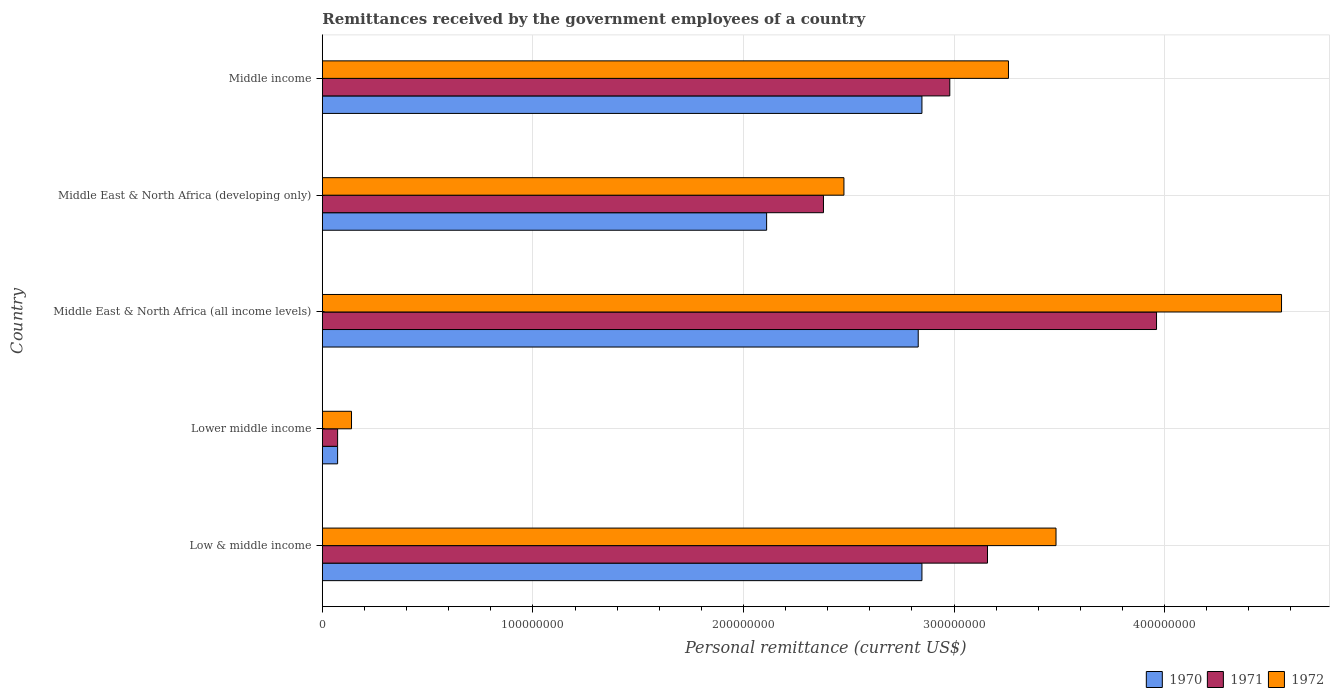How many different coloured bars are there?
Your response must be concise. 3. Are the number of bars on each tick of the Y-axis equal?
Ensure brevity in your answer.  Yes. How many bars are there on the 3rd tick from the top?
Offer a very short reply. 3. What is the remittances received by the government employees in 1970 in Lower middle income?
Your response must be concise. 7.26e+06. Across all countries, what is the maximum remittances received by the government employees in 1970?
Give a very brief answer. 2.85e+08. Across all countries, what is the minimum remittances received by the government employees in 1970?
Keep it short and to the point. 7.26e+06. In which country was the remittances received by the government employees in 1972 maximum?
Keep it short and to the point. Middle East & North Africa (all income levels). In which country was the remittances received by the government employees in 1971 minimum?
Provide a succinct answer. Lower middle income. What is the total remittances received by the government employees in 1972 in the graph?
Your response must be concise. 1.39e+09. What is the difference between the remittances received by the government employees in 1971 in Low & middle income and that in Lower middle income?
Make the answer very short. 3.09e+08. What is the difference between the remittances received by the government employees in 1971 in Lower middle income and the remittances received by the government employees in 1972 in Low & middle income?
Offer a very short reply. -3.41e+08. What is the average remittances received by the government employees in 1970 per country?
Your response must be concise. 2.14e+08. What is the difference between the remittances received by the government employees in 1970 and remittances received by the government employees in 1971 in Low & middle income?
Your answer should be very brief. -3.11e+07. In how many countries, is the remittances received by the government employees in 1972 greater than 180000000 US$?
Your response must be concise. 4. What is the ratio of the remittances received by the government employees in 1972 in Low & middle income to that in Middle income?
Your response must be concise. 1.07. Is the difference between the remittances received by the government employees in 1970 in Middle East & North Africa (all income levels) and Middle income greater than the difference between the remittances received by the government employees in 1971 in Middle East & North Africa (all income levels) and Middle income?
Give a very brief answer. No. What is the difference between the highest and the second highest remittances received by the government employees in 1971?
Ensure brevity in your answer.  8.03e+07. What is the difference between the highest and the lowest remittances received by the government employees in 1970?
Your response must be concise. 2.77e+08. In how many countries, is the remittances received by the government employees in 1970 greater than the average remittances received by the government employees in 1970 taken over all countries?
Provide a short and direct response. 3. What does the 2nd bar from the top in Middle income represents?
Give a very brief answer. 1971. How many bars are there?
Your response must be concise. 15. How many countries are there in the graph?
Offer a very short reply. 5. What is the difference between two consecutive major ticks on the X-axis?
Provide a succinct answer. 1.00e+08. Does the graph contain any zero values?
Make the answer very short. No. Where does the legend appear in the graph?
Ensure brevity in your answer.  Bottom right. How many legend labels are there?
Offer a very short reply. 3. What is the title of the graph?
Give a very brief answer. Remittances received by the government employees of a country. What is the label or title of the X-axis?
Your answer should be very brief. Personal remittance (current US$). What is the label or title of the Y-axis?
Your answer should be compact. Country. What is the Personal remittance (current US$) in 1970 in Low & middle income?
Offer a very short reply. 2.85e+08. What is the Personal remittance (current US$) in 1971 in Low & middle income?
Give a very brief answer. 3.16e+08. What is the Personal remittance (current US$) in 1972 in Low & middle income?
Keep it short and to the point. 3.48e+08. What is the Personal remittance (current US$) of 1970 in Lower middle income?
Your answer should be very brief. 7.26e+06. What is the Personal remittance (current US$) of 1971 in Lower middle income?
Provide a short and direct response. 7.26e+06. What is the Personal remittance (current US$) of 1972 in Lower middle income?
Give a very brief answer. 1.39e+07. What is the Personal remittance (current US$) in 1970 in Middle East & North Africa (all income levels)?
Ensure brevity in your answer.  2.83e+08. What is the Personal remittance (current US$) of 1971 in Middle East & North Africa (all income levels)?
Your response must be concise. 3.96e+08. What is the Personal remittance (current US$) in 1972 in Middle East & North Africa (all income levels)?
Offer a very short reply. 4.56e+08. What is the Personal remittance (current US$) of 1970 in Middle East & North Africa (developing only)?
Your answer should be very brief. 2.11e+08. What is the Personal remittance (current US$) of 1971 in Middle East & North Africa (developing only)?
Give a very brief answer. 2.38e+08. What is the Personal remittance (current US$) in 1972 in Middle East & North Africa (developing only)?
Offer a very short reply. 2.48e+08. What is the Personal remittance (current US$) in 1970 in Middle income?
Give a very brief answer. 2.85e+08. What is the Personal remittance (current US$) in 1971 in Middle income?
Your answer should be compact. 2.98e+08. What is the Personal remittance (current US$) in 1972 in Middle income?
Offer a very short reply. 3.26e+08. Across all countries, what is the maximum Personal remittance (current US$) in 1970?
Your answer should be compact. 2.85e+08. Across all countries, what is the maximum Personal remittance (current US$) in 1971?
Your answer should be compact. 3.96e+08. Across all countries, what is the maximum Personal remittance (current US$) of 1972?
Give a very brief answer. 4.56e+08. Across all countries, what is the minimum Personal remittance (current US$) of 1970?
Your answer should be very brief. 7.26e+06. Across all countries, what is the minimum Personal remittance (current US$) of 1971?
Your answer should be compact. 7.26e+06. Across all countries, what is the minimum Personal remittance (current US$) of 1972?
Offer a terse response. 1.39e+07. What is the total Personal remittance (current US$) of 1970 in the graph?
Your answer should be very brief. 1.07e+09. What is the total Personal remittance (current US$) in 1971 in the graph?
Your response must be concise. 1.26e+09. What is the total Personal remittance (current US$) of 1972 in the graph?
Give a very brief answer. 1.39e+09. What is the difference between the Personal remittance (current US$) of 1970 in Low & middle income and that in Lower middle income?
Your answer should be very brief. 2.77e+08. What is the difference between the Personal remittance (current US$) in 1971 in Low & middle income and that in Lower middle income?
Provide a succinct answer. 3.09e+08. What is the difference between the Personal remittance (current US$) of 1972 in Low & middle income and that in Lower middle income?
Your response must be concise. 3.35e+08. What is the difference between the Personal remittance (current US$) in 1970 in Low & middle income and that in Middle East & North Africa (all income levels)?
Make the answer very short. 1.76e+06. What is the difference between the Personal remittance (current US$) in 1971 in Low & middle income and that in Middle East & North Africa (all income levels)?
Provide a succinct answer. -8.03e+07. What is the difference between the Personal remittance (current US$) of 1972 in Low & middle income and that in Middle East & North Africa (all income levels)?
Ensure brevity in your answer.  -1.07e+08. What is the difference between the Personal remittance (current US$) in 1970 in Low & middle income and that in Middle East & North Africa (developing only)?
Your answer should be compact. 7.38e+07. What is the difference between the Personal remittance (current US$) of 1971 in Low & middle income and that in Middle East & North Africa (developing only)?
Make the answer very short. 7.79e+07. What is the difference between the Personal remittance (current US$) in 1972 in Low & middle income and that in Middle East & North Africa (developing only)?
Keep it short and to the point. 1.01e+08. What is the difference between the Personal remittance (current US$) in 1970 in Low & middle income and that in Middle income?
Keep it short and to the point. 0. What is the difference between the Personal remittance (current US$) in 1971 in Low & middle income and that in Middle income?
Ensure brevity in your answer.  1.79e+07. What is the difference between the Personal remittance (current US$) of 1972 in Low & middle income and that in Middle income?
Give a very brief answer. 2.26e+07. What is the difference between the Personal remittance (current US$) in 1970 in Lower middle income and that in Middle East & North Africa (all income levels)?
Give a very brief answer. -2.76e+08. What is the difference between the Personal remittance (current US$) in 1971 in Lower middle income and that in Middle East & North Africa (all income levels)?
Make the answer very short. -3.89e+08. What is the difference between the Personal remittance (current US$) of 1972 in Lower middle income and that in Middle East & North Africa (all income levels)?
Offer a very short reply. -4.42e+08. What is the difference between the Personal remittance (current US$) in 1970 in Lower middle income and that in Middle East & North Africa (developing only)?
Your answer should be very brief. -2.04e+08. What is the difference between the Personal remittance (current US$) in 1971 in Lower middle income and that in Middle East & North Africa (developing only)?
Offer a very short reply. -2.31e+08. What is the difference between the Personal remittance (current US$) of 1972 in Lower middle income and that in Middle East & North Africa (developing only)?
Ensure brevity in your answer.  -2.34e+08. What is the difference between the Personal remittance (current US$) of 1970 in Lower middle income and that in Middle income?
Your response must be concise. -2.77e+08. What is the difference between the Personal remittance (current US$) of 1971 in Lower middle income and that in Middle income?
Ensure brevity in your answer.  -2.91e+08. What is the difference between the Personal remittance (current US$) in 1972 in Lower middle income and that in Middle income?
Your answer should be compact. -3.12e+08. What is the difference between the Personal remittance (current US$) in 1970 in Middle East & North Africa (all income levels) and that in Middle East & North Africa (developing only)?
Give a very brief answer. 7.20e+07. What is the difference between the Personal remittance (current US$) of 1971 in Middle East & North Africa (all income levels) and that in Middle East & North Africa (developing only)?
Your answer should be compact. 1.58e+08. What is the difference between the Personal remittance (current US$) of 1972 in Middle East & North Africa (all income levels) and that in Middle East & North Africa (developing only)?
Ensure brevity in your answer.  2.08e+08. What is the difference between the Personal remittance (current US$) of 1970 in Middle East & North Africa (all income levels) and that in Middle income?
Provide a succinct answer. -1.76e+06. What is the difference between the Personal remittance (current US$) of 1971 in Middle East & North Africa (all income levels) and that in Middle income?
Your answer should be very brief. 9.82e+07. What is the difference between the Personal remittance (current US$) of 1972 in Middle East & North Africa (all income levels) and that in Middle income?
Provide a succinct answer. 1.30e+08. What is the difference between the Personal remittance (current US$) of 1970 in Middle East & North Africa (developing only) and that in Middle income?
Ensure brevity in your answer.  -7.38e+07. What is the difference between the Personal remittance (current US$) of 1971 in Middle East & North Africa (developing only) and that in Middle income?
Offer a very short reply. -6.00e+07. What is the difference between the Personal remittance (current US$) in 1972 in Middle East & North Africa (developing only) and that in Middle income?
Provide a succinct answer. -7.81e+07. What is the difference between the Personal remittance (current US$) of 1970 in Low & middle income and the Personal remittance (current US$) of 1971 in Lower middle income?
Offer a terse response. 2.77e+08. What is the difference between the Personal remittance (current US$) of 1970 in Low & middle income and the Personal remittance (current US$) of 1972 in Lower middle income?
Your answer should be compact. 2.71e+08. What is the difference between the Personal remittance (current US$) in 1971 in Low & middle income and the Personal remittance (current US$) in 1972 in Lower middle income?
Offer a terse response. 3.02e+08. What is the difference between the Personal remittance (current US$) in 1970 in Low & middle income and the Personal remittance (current US$) in 1971 in Middle East & North Africa (all income levels)?
Provide a succinct answer. -1.11e+08. What is the difference between the Personal remittance (current US$) of 1970 in Low & middle income and the Personal remittance (current US$) of 1972 in Middle East & North Africa (all income levels)?
Keep it short and to the point. -1.71e+08. What is the difference between the Personal remittance (current US$) of 1971 in Low & middle income and the Personal remittance (current US$) of 1972 in Middle East & North Africa (all income levels)?
Make the answer very short. -1.40e+08. What is the difference between the Personal remittance (current US$) of 1970 in Low & middle income and the Personal remittance (current US$) of 1971 in Middle East & North Africa (developing only)?
Your answer should be compact. 4.68e+07. What is the difference between the Personal remittance (current US$) in 1970 in Low & middle income and the Personal remittance (current US$) in 1972 in Middle East & North Africa (developing only)?
Offer a very short reply. 3.70e+07. What is the difference between the Personal remittance (current US$) of 1971 in Low & middle income and the Personal remittance (current US$) of 1972 in Middle East & North Africa (developing only)?
Offer a terse response. 6.82e+07. What is the difference between the Personal remittance (current US$) of 1970 in Low & middle income and the Personal remittance (current US$) of 1971 in Middle income?
Ensure brevity in your answer.  -1.32e+07. What is the difference between the Personal remittance (current US$) in 1970 in Low & middle income and the Personal remittance (current US$) in 1972 in Middle income?
Offer a very short reply. -4.11e+07. What is the difference between the Personal remittance (current US$) of 1971 in Low & middle income and the Personal remittance (current US$) of 1972 in Middle income?
Give a very brief answer. -9.96e+06. What is the difference between the Personal remittance (current US$) in 1970 in Lower middle income and the Personal remittance (current US$) in 1971 in Middle East & North Africa (all income levels)?
Your answer should be very brief. -3.89e+08. What is the difference between the Personal remittance (current US$) of 1970 in Lower middle income and the Personal remittance (current US$) of 1972 in Middle East & North Africa (all income levels)?
Your answer should be compact. -4.48e+08. What is the difference between the Personal remittance (current US$) in 1971 in Lower middle income and the Personal remittance (current US$) in 1972 in Middle East & North Africa (all income levels)?
Offer a very short reply. -4.48e+08. What is the difference between the Personal remittance (current US$) of 1970 in Lower middle income and the Personal remittance (current US$) of 1971 in Middle East & North Africa (developing only)?
Your response must be concise. -2.31e+08. What is the difference between the Personal remittance (current US$) in 1970 in Lower middle income and the Personal remittance (current US$) in 1972 in Middle East & North Africa (developing only)?
Your answer should be compact. -2.40e+08. What is the difference between the Personal remittance (current US$) of 1971 in Lower middle income and the Personal remittance (current US$) of 1972 in Middle East & North Africa (developing only)?
Provide a short and direct response. -2.40e+08. What is the difference between the Personal remittance (current US$) of 1970 in Lower middle income and the Personal remittance (current US$) of 1971 in Middle income?
Your response must be concise. -2.91e+08. What is the difference between the Personal remittance (current US$) in 1970 in Lower middle income and the Personal remittance (current US$) in 1972 in Middle income?
Provide a succinct answer. -3.19e+08. What is the difference between the Personal remittance (current US$) of 1971 in Lower middle income and the Personal remittance (current US$) of 1972 in Middle income?
Provide a succinct answer. -3.19e+08. What is the difference between the Personal remittance (current US$) in 1970 in Middle East & North Africa (all income levels) and the Personal remittance (current US$) in 1971 in Middle East & North Africa (developing only)?
Provide a succinct answer. 4.50e+07. What is the difference between the Personal remittance (current US$) in 1970 in Middle East & North Africa (all income levels) and the Personal remittance (current US$) in 1972 in Middle East & North Africa (developing only)?
Keep it short and to the point. 3.53e+07. What is the difference between the Personal remittance (current US$) in 1971 in Middle East & North Africa (all income levels) and the Personal remittance (current US$) in 1972 in Middle East & North Africa (developing only)?
Make the answer very short. 1.48e+08. What is the difference between the Personal remittance (current US$) in 1970 in Middle East & North Africa (all income levels) and the Personal remittance (current US$) in 1971 in Middle income?
Your response must be concise. -1.50e+07. What is the difference between the Personal remittance (current US$) of 1970 in Middle East & North Africa (all income levels) and the Personal remittance (current US$) of 1972 in Middle income?
Ensure brevity in your answer.  -4.29e+07. What is the difference between the Personal remittance (current US$) of 1971 in Middle East & North Africa (all income levels) and the Personal remittance (current US$) of 1972 in Middle income?
Ensure brevity in your answer.  7.03e+07. What is the difference between the Personal remittance (current US$) of 1970 in Middle East & North Africa (developing only) and the Personal remittance (current US$) of 1971 in Middle income?
Your answer should be very brief. -8.70e+07. What is the difference between the Personal remittance (current US$) of 1970 in Middle East & North Africa (developing only) and the Personal remittance (current US$) of 1972 in Middle income?
Offer a terse response. -1.15e+08. What is the difference between the Personal remittance (current US$) of 1971 in Middle East & North Africa (developing only) and the Personal remittance (current US$) of 1972 in Middle income?
Ensure brevity in your answer.  -8.79e+07. What is the average Personal remittance (current US$) of 1970 per country?
Your answer should be compact. 2.14e+08. What is the average Personal remittance (current US$) of 1971 per country?
Your response must be concise. 2.51e+08. What is the average Personal remittance (current US$) in 1972 per country?
Ensure brevity in your answer.  2.78e+08. What is the difference between the Personal remittance (current US$) of 1970 and Personal remittance (current US$) of 1971 in Low & middle income?
Your response must be concise. -3.11e+07. What is the difference between the Personal remittance (current US$) in 1970 and Personal remittance (current US$) in 1972 in Low & middle income?
Offer a terse response. -6.37e+07. What is the difference between the Personal remittance (current US$) in 1971 and Personal remittance (current US$) in 1972 in Low & middle income?
Offer a terse response. -3.25e+07. What is the difference between the Personal remittance (current US$) in 1970 and Personal remittance (current US$) in 1972 in Lower middle income?
Give a very brief answer. -6.60e+06. What is the difference between the Personal remittance (current US$) in 1971 and Personal remittance (current US$) in 1972 in Lower middle income?
Make the answer very short. -6.60e+06. What is the difference between the Personal remittance (current US$) in 1970 and Personal remittance (current US$) in 1971 in Middle East & North Africa (all income levels)?
Offer a very short reply. -1.13e+08. What is the difference between the Personal remittance (current US$) in 1970 and Personal remittance (current US$) in 1972 in Middle East & North Africa (all income levels)?
Keep it short and to the point. -1.73e+08. What is the difference between the Personal remittance (current US$) in 1971 and Personal remittance (current US$) in 1972 in Middle East & North Africa (all income levels)?
Your answer should be compact. -5.94e+07. What is the difference between the Personal remittance (current US$) in 1970 and Personal remittance (current US$) in 1971 in Middle East & North Africa (developing only)?
Give a very brief answer. -2.70e+07. What is the difference between the Personal remittance (current US$) of 1970 and Personal remittance (current US$) of 1972 in Middle East & North Africa (developing only)?
Keep it short and to the point. -3.67e+07. What is the difference between the Personal remittance (current US$) of 1971 and Personal remittance (current US$) of 1972 in Middle East & North Africa (developing only)?
Make the answer very short. -9.72e+06. What is the difference between the Personal remittance (current US$) of 1970 and Personal remittance (current US$) of 1971 in Middle income?
Give a very brief answer. -1.32e+07. What is the difference between the Personal remittance (current US$) in 1970 and Personal remittance (current US$) in 1972 in Middle income?
Make the answer very short. -4.11e+07. What is the difference between the Personal remittance (current US$) in 1971 and Personal remittance (current US$) in 1972 in Middle income?
Offer a very short reply. -2.79e+07. What is the ratio of the Personal remittance (current US$) in 1970 in Low & middle income to that in Lower middle income?
Offer a very short reply. 39.22. What is the ratio of the Personal remittance (current US$) of 1971 in Low & middle income to that in Lower middle income?
Provide a short and direct response. 43.51. What is the ratio of the Personal remittance (current US$) in 1972 in Low & middle income to that in Lower middle income?
Keep it short and to the point. 25.14. What is the ratio of the Personal remittance (current US$) in 1971 in Low & middle income to that in Middle East & North Africa (all income levels)?
Offer a very short reply. 0.8. What is the ratio of the Personal remittance (current US$) of 1972 in Low & middle income to that in Middle East & North Africa (all income levels)?
Give a very brief answer. 0.76. What is the ratio of the Personal remittance (current US$) in 1970 in Low & middle income to that in Middle East & North Africa (developing only)?
Offer a terse response. 1.35. What is the ratio of the Personal remittance (current US$) in 1971 in Low & middle income to that in Middle East & North Africa (developing only)?
Provide a succinct answer. 1.33. What is the ratio of the Personal remittance (current US$) of 1972 in Low & middle income to that in Middle East & North Africa (developing only)?
Make the answer very short. 1.41. What is the ratio of the Personal remittance (current US$) in 1970 in Low & middle income to that in Middle income?
Offer a very short reply. 1. What is the ratio of the Personal remittance (current US$) of 1971 in Low & middle income to that in Middle income?
Your answer should be compact. 1.06. What is the ratio of the Personal remittance (current US$) in 1972 in Low & middle income to that in Middle income?
Provide a short and direct response. 1.07. What is the ratio of the Personal remittance (current US$) in 1970 in Lower middle income to that in Middle East & North Africa (all income levels)?
Make the answer very short. 0.03. What is the ratio of the Personal remittance (current US$) of 1971 in Lower middle income to that in Middle East & North Africa (all income levels)?
Offer a very short reply. 0.02. What is the ratio of the Personal remittance (current US$) in 1972 in Lower middle income to that in Middle East & North Africa (all income levels)?
Keep it short and to the point. 0.03. What is the ratio of the Personal remittance (current US$) in 1970 in Lower middle income to that in Middle East & North Africa (developing only)?
Ensure brevity in your answer.  0.03. What is the ratio of the Personal remittance (current US$) in 1971 in Lower middle income to that in Middle East & North Africa (developing only)?
Keep it short and to the point. 0.03. What is the ratio of the Personal remittance (current US$) in 1972 in Lower middle income to that in Middle East & North Africa (developing only)?
Give a very brief answer. 0.06. What is the ratio of the Personal remittance (current US$) of 1970 in Lower middle income to that in Middle income?
Your answer should be very brief. 0.03. What is the ratio of the Personal remittance (current US$) of 1971 in Lower middle income to that in Middle income?
Provide a short and direct response. 0.02. What is the ratio of the Personal remittance (current US$) of 1972 in Lower middle income to that in Middle income?
Offer a terse response. 0.04. What is the ratio of the Personal remittance (current US$) in 1970 in Middle East & North Africa (all income levels) to that in Middle East & North Africa (developing only)?
Offer a very short reply. 1.34. What is the ratio of the Personal remittance (current US$) in 1971 in Middle East & North Africa (all income levels) to that in Middle East & North Africa (developing only)?
Your answer should be compact. 1.66. What is the ratio of the Personal remittance (current US$) of 1972 in Middle East & North Africa (all income levels) to that in Middle East & North Africa (developing only)?
Give a very brief answer. 1.84. What is the ratio of the Personal remittance (current US$) of 1971 in Middle East & North Africa (all income levels) to that in Middle income?
Your answer should be very brief. 1.33. What is the ratio of the Personal remittance (current US$) of 1972 in Middle East & North Africa (all income levels) to that in Middle income?
Provide a succinct answer. 1.4. What is the ratio of the Personal remittance (current US$) of 1970 in Middle East & North Africa (developing only) to that in Middle income?
Give a very brief answer. 0.74. What is the ratio of the Personal remittance (current US$) of 1971 in Middle East & North Africa (developing only) to that in Middle income?
Your response must be concise. 0.8. What is the ratio of the Personal remittance (current US$) in 1972 in Middle East & North Africa (developing only) to that in Middle income?
Offer a very short reply. 0.76. What is the difference between the highest and the second highest Personal remittance (current US$) of 1970?
Keep it short and to the point. 0. What is the difference between the highest and the second highest Personal remittance (current US$) of 1971?
Give a very brief answer. 8.03e+07. What is the difference between the highest and the second highest Personal remittance (current US$) of 1972?
Offer a very short reply. 1.07e+08. What is the difference between the highest and the lowest Personal remittance (current US$) of 1970?
Give a very brief answer. 2.77e+08. What is the difference between the highest and the lowest Personal remittance (current US$) of 1971?
Keep it short and to the point. 3.89e+08. What is the difference between the highest and the lowest Personal remittance (current US$) of 1972?
Your answer should be compact. 4.42e+08. 